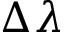Convert formula to latex. <formula><loc_0><loc_0><loc_500><loc_500>\Delta \lambda</formula> 